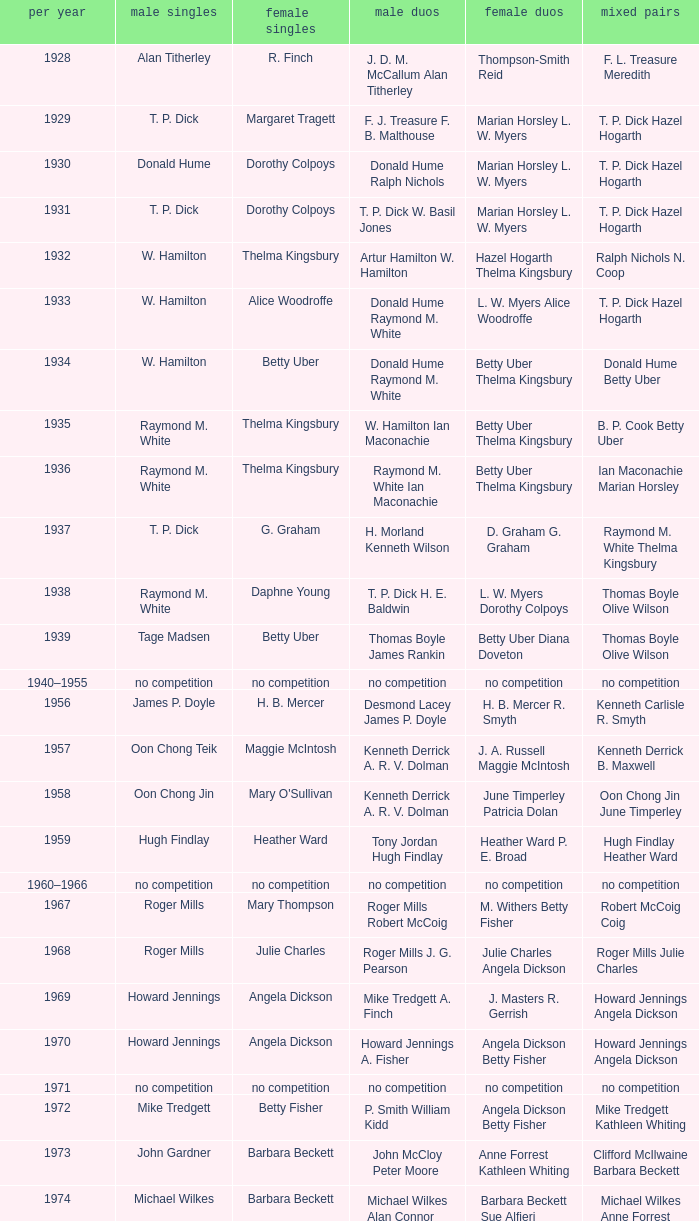Who won the Women's singles, in the year that Raymond M. White won the Men's singles and that W. Hamilton Ian Maconachie won the Men's doubles? Thelma Kingsbury. 